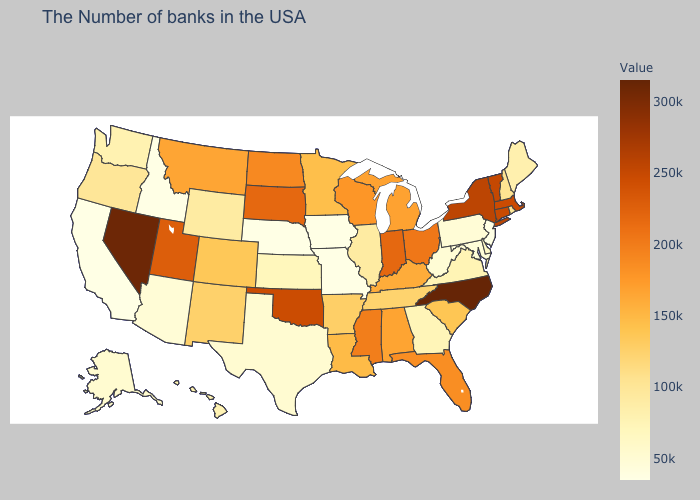Does North Carolina have the highest value in the USA?
Be succinct. Yes. Which states have the highest value in the USA?
Short answer required. North Carolina. Does Arizona have the lowest value in the USA?
Be succinct. No. Does Oregon have a lower value than Nebraska?
Concise answer only. No. 